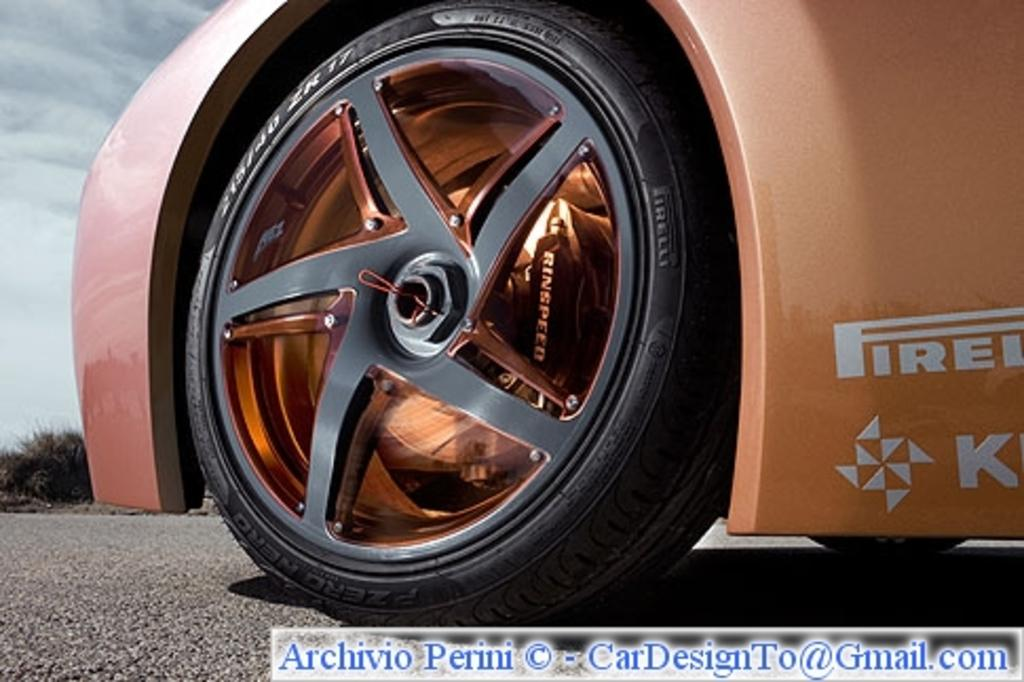What is the main subject of the image? The main subject of the image is tiers of a car on the road. What can be seen in the background of the image? There are trees and sky visible in the background of the image. Is there any text present in the image? Yes, there is some text at the bottom of the image. How far away is the son from the car in the image? There is no son present in the image, so it is not possible to determine the distance between a son and the car. 